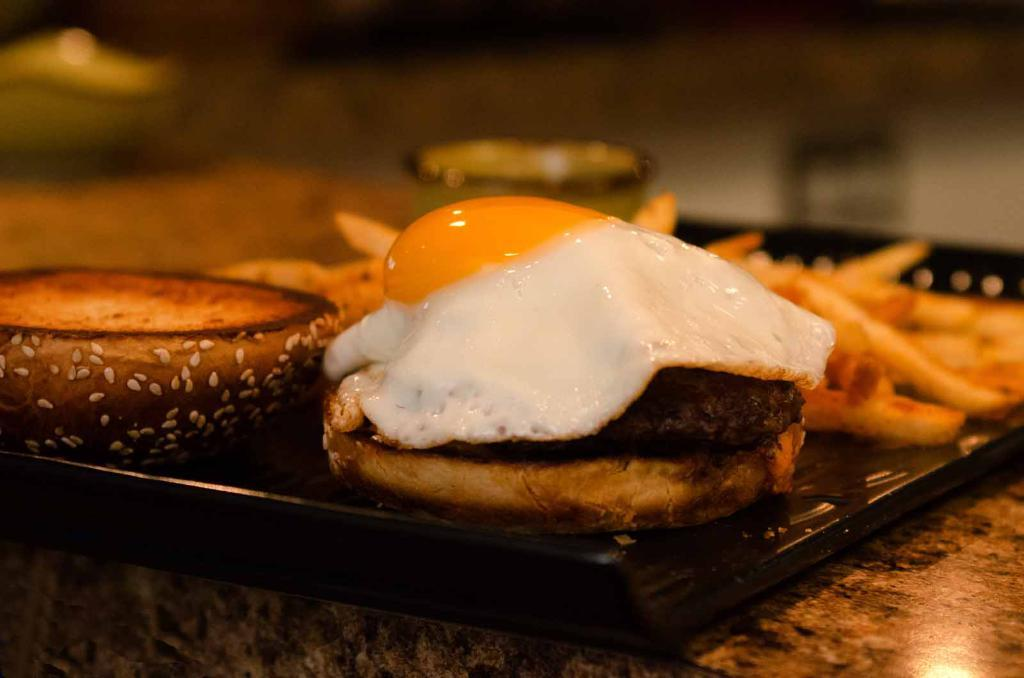What type of objects are present in the image? There are food items in the image. What is the color of the object on which the food items are placed? The food items are on a black object. Can you describe the surface on which the black object is placed? The black object is on a platform. How would you describe the background of the image? The background of the image is blurred. What advice does the cook give about the food items in the image? There is no cook present in the image, and therefore no advice can be given about the food items. 